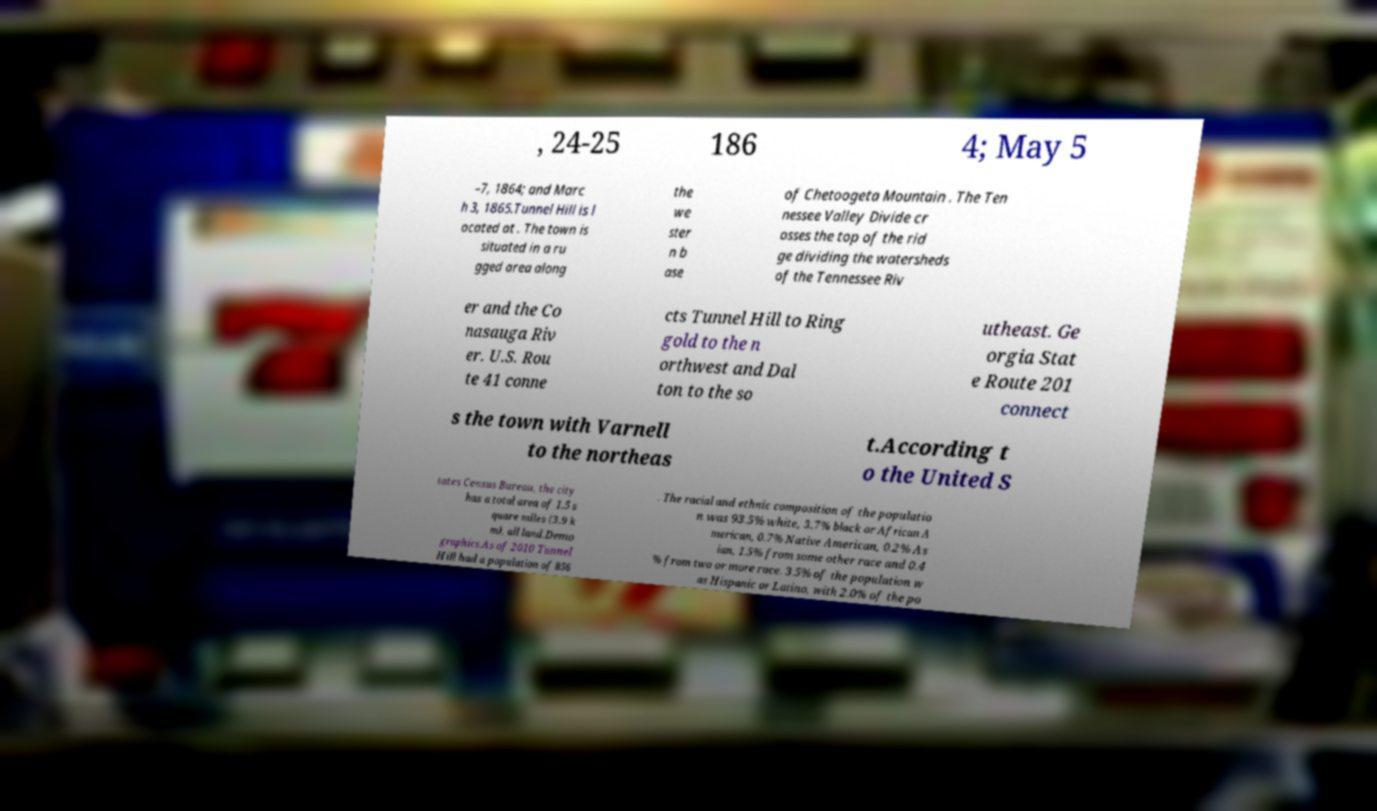For documentation purposes, I need the text within this image transcribed. Could you provide that? , 24-25 186 4; May 5 –7, 1864; and Marc h 3, 1865.Tunnel Hill is l ocated at . The town is situated in a ru gged area along the we ster n b ase of Chetoogeta Mountain . The Ten nessee Valley Divide cr osses the top of the rid ge dividing the watersheds of the Tennessee Riv er and the Co nasauga Riv er. U.S. Rou te 41 conne cts Tunnel Hill to Ring gold to the n orthwest and Dal ton to the so utheast. Ge orgia Stat e Route 201 connect s the town with Varnell to the northeas t.According t o the United S tates Census Bureau, the city has a total area of 1.5 s quare miles (3.9 k m), all land.Demo graphics.As of 2010 Tunnel Hill had a population of 856 . The racial and ethnic composition of the populatio n was 93.5% white, 3.7% black or African A merican, 0.7% Native American, 0.2% As ian, 1.5% from some other race and 0.4 % from two or more race. 3.5% of the population w as Hispanic or Latino, with 2.0% of the po 